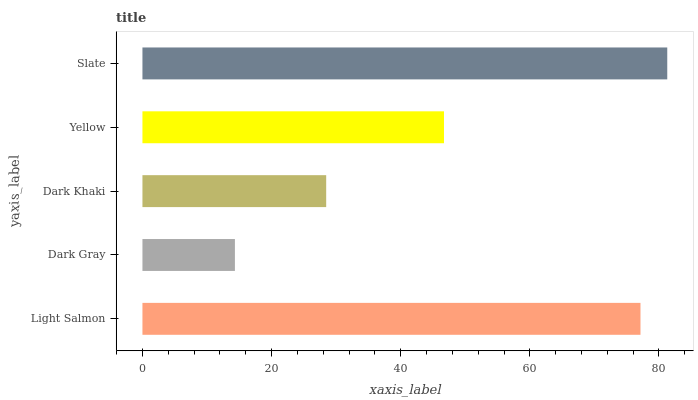Is Dark Gray the minimum?
Answer yes or no. Yes. Is Slate the maximum?
Answer yes or no. Yes. Is Dark Khaki the minimum?
Answer yes or no. No. Is Dark Khaki the maximum?
Answer yes or no. No. Is Dark Khaki greater than Dark Gray?
Answer yes or no. Yes. Is Dark Gray less than Dark Khaki?
Answer yes or no. Yes. Is Dark Gray greater than Dark Khaki?
Answer yes or no. No. Is Dark Khaki less than Dark Gray?
Answer yes or no. No. Is Yellow the high median?
Answer yes or no. Yes. Is Yellow the low median?
Answer yes or no. Yes. Is Dark Gray the high median?
Answer yes or no. No. Is Dark Gray the low median?
Answer yes or no. No. 